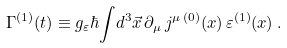Convert formula to latex. <formula><loc_0><loc_0><loc_500><loc_500>\Gamma ^ { ( 1 ) } ( t ) \equiv g _ { \varepsilon } \hbar { \int } d ^ { 3 } \vec { x } \, \partial _ { \mu } \, j ^ { \mu \, ( 0 ) } ( x ) \, \varepsilon ^ { ( 1 ) } ( x ) \, .</formula> 